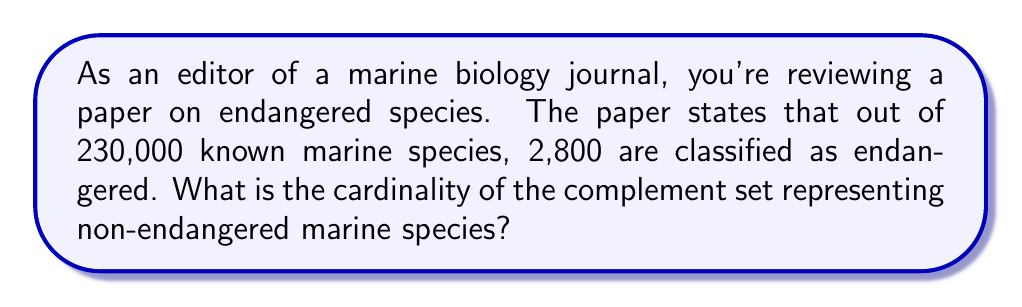What is the answer to this math problem? Let's approach this step-by-step using set theory:

1) Define our universal set $U$ as all known marine species:
   $|U| = 230,000$

2) Let $E$ be the set of endangered marine species:
   $|E| = 2,800$

3) We're asked to find the complement of $E$ within $U$, which we can denote as $E^c$

4) In set theory, the complement of a set $A$ within a universal set $U$ is defined as all elements in $U$ that are not in $A$

5) The cardinality of a complement set can be calculated using the formula:
   $|E^c| = |U| - |E|$

6) Substituting our values:
   $|E^c| = 230,000 - 2,800$

7) Calculating:
   $|E^c| = 227,200$

Therefore, the cardinality of the complement set representing non-endangered marine species is 227,200.
Answer: $|E^c| = 227,200$ 